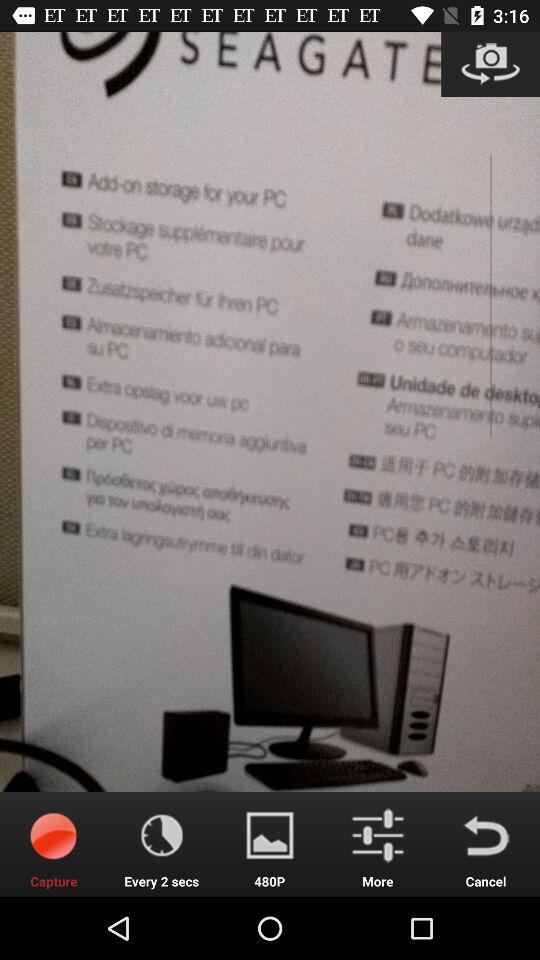What is the given click time? The given click time is every 2 seconds. 